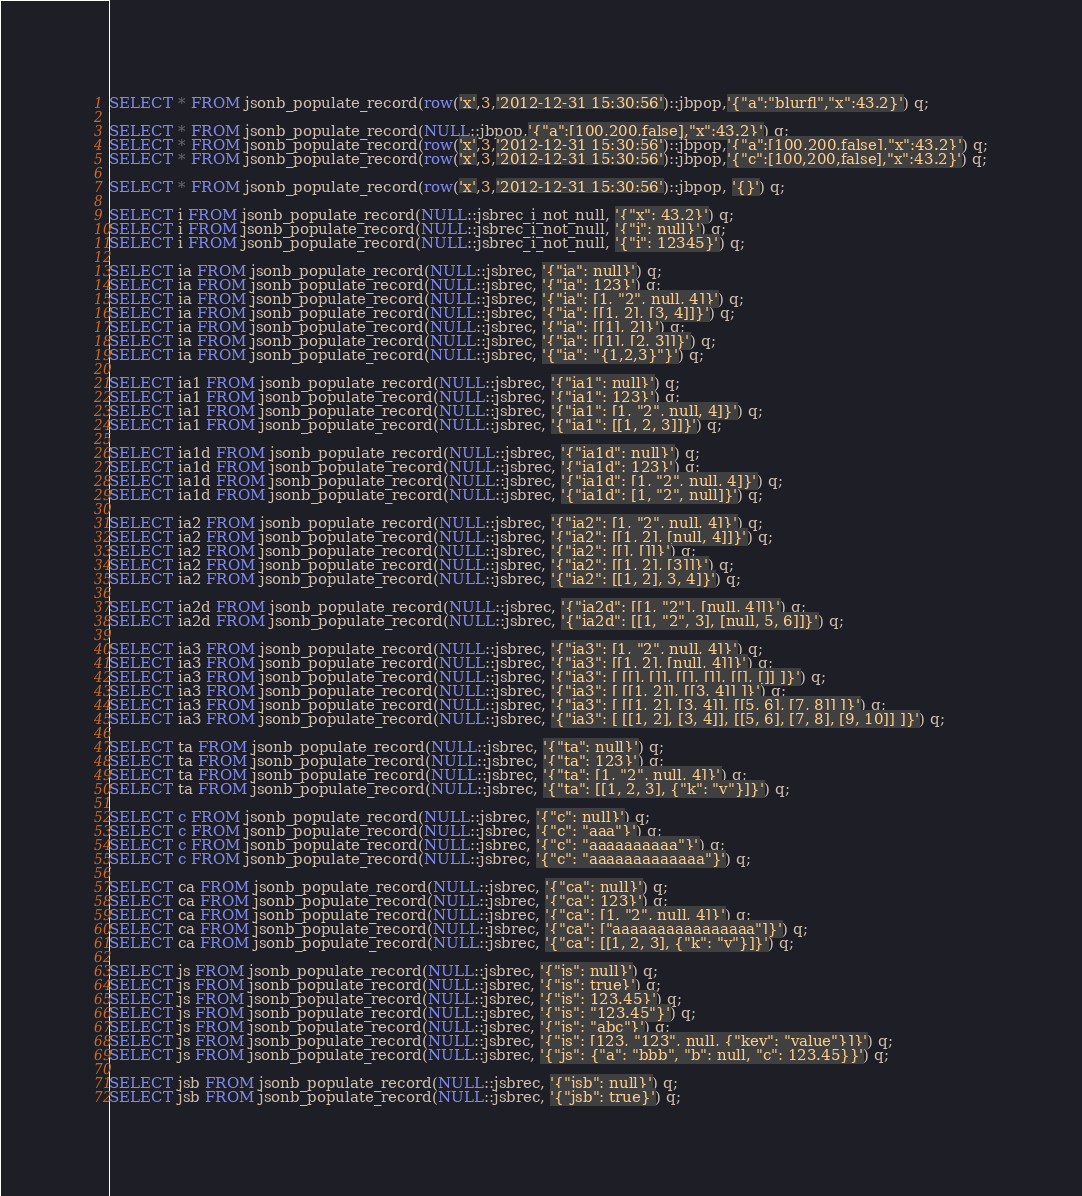Convert code to text. <code><loc_0><loc_0><loc_500><loc_500><_SQL_>SELECT * FROM jsonb_populate_record(row('x',3,'2012-12-31 15:30:56')::jbpop,'{"a":"blurfl","x":43.2}') q;

SELECT * FROM jsonb_populate_record(NULL::jbpop,'{"a":[100,200,false],"x":43.2}') q;
SELECT * FROM jsonb_populate_record(row('x',3,'2012-12-31 15:30:56')::jbpop,'{"a":[100,200,false],"x":43.2}') q;
SELECT * FROM jsonb_populate_record(row('x',3,'2012-12-31 15:30:56')::jbpop,'{"c":[100,200,false],"x":43.2}') q;

SELECT * FROM jsonb_populate_record(row('x',3,'2012-12-31 15:30:56')::jbpop, '{}') q;

SELECT i FROM jsonb_populate_record(NULL::jsbrec_i_not_null, '{"x": 43.2}') q;
SELECT i FROM jsonb_populate_record(NULL::jsbrec_i_not_null, '{"i": null}') q;
SELECT i FROM jsonb_populate_record(NULL::jsbrec_i_not_null, '{"i": 12345}') q;

SELECT ia FROM jsonb_populate_record(NULL::jsbrec, '{"ia": null}') q;
SELECT ia FROM jsonb_populate_record(NULL::jsbrec, '{"ia": 123}') q;
SELECT ia FROM jsonb_populate_record(NULL::jsbrec, '{"ia": [1, "2", null, 4]}') q;
SELECT ia FROM jsonb_populate_record(NULL::jsbrec, '{"ia": [[1, 2], [3, 4]]}') q;
SELECT ia FROM jsonb_populate_record(NULL::jsbrec, '{"ia": [[1], 2]}') q;
SELECT ia FROM jsonb_populate_record(NULL::jsbrec, '{"ia": [[1], [2, 3]]}') q;
SELECT ia FROM jsonb_populate_record(NULL::jsbrec, '{"ia": "{1,2,3}"}') q;

SELECT ia1 FROM jsonb_populate_record(NULL::jsbrec, '{"ia1": null}') q;
SELECT ia1 FROM jsonb_populate_record(NULL::jsbrec, '{"ia1": 123}') q;
SELECT ia1 FROM jsonb_populate_record(NULL::jsbrec, '{"ia1": [1, "2", null, 4]}') q;
SELECT ia1 FROM jsonb_populate_record(NULL::jsbrec, '{"ia1": [[1, 2, 3]]}') q;

SELECT ia1d FROM jsonb_populate_record(NULL::jsbrec, '{"ia1d": null}') q;
SELECT ia1d FROM jsonb_populate_record(NULL::jsbrec, '{"ia1d": 123}') q;
SELECT ia1d FROM jsonb_populate_record(NULL::jsbrec, '{"ia1d": [1, "2", null, 4]}') q;
SELECT ia1d FROM jsonb_populate_record(NULL::jsbrec, '{"ia1d": [1, "2", null]}') q;

SELECT ia2 FROM jsonb_populate_record(NULL::jsbrec, '{"ia2": [1, "2", null, 4]}') q;
SELECT ia2 FROM jsonb_populate_record(NULL::jsbrec, '{"ia2": [[1, 2], [null, 4]]}') q;
SELECT ia2 FROM jsonb_populate_record(NULL::jsbrec, '{"ia2": [[], []]}') q;
SELECT ia2 FROM jsonb_populate_record(NULL::jsbrec, '{"ia2": [[1, 2], [3]]}') q;
SELECT ia2 FROM jsonb_populate_record(NULL::jsbrec, '{"ia2": [[1, 2], 3, 4]}') q;

SELECT ia2d FROM jsonb_populate_record(NULL::jsbrec, '{"ia2d": [[1, "2"], [null, 4]]}') q;
SELECT ia2d FROM jsonb_populate_record(NULL::jsbrec, '{"ia2d": [[1, "2", 3], [null, 5, 6]]}') q;

SELECT ia3 FROM jsonb_populate_record(NULL::jsbrec, '{"ia3": [1, "2", null, 4]}') q;
SELECT ia3 FROM jsonb_populate_record(NULL::jsbrec, '{"ia3": [[1, 2], [null, 4]]}') q;
SELECT ia3 FROM jsonb_populate_record(NULL::jsbrec, '{"ia3": [ [[], []], [[], []], [[], []] ]}') q;
SELECT ia3 FROM jsonb_populate_record(NULL::jsbrec, '{"ia3": [ [[1, 2]], [[3, 4]] ]}') q;
SELECT ia3 FROM jsonb_populate_record(NULL::jsbrec, '{"ia3": [ [[1, 2], [3, 4]], [[5, 6], [7, 8]] ]}') q;
SELECT ia3 FROM jsonb_populate_record(NULL::jsbrec, '{"ia3": [ [[1, 2], [3, 4]], [[5, 6], [7, 8], [9, 10]] ]}') q;

SELECT ta FROM jsonb_populate_record(NULL::jsbrec, '{"ta": null}') q;
SELECT ta FROM jsonb_populate_record(NULL::jsbrec, '{"ta": 123}') q;
SELECT ta FROM jsonb_populate_record(NULL::jsbrec, '{"ta": [1, "2", null, 4]}') q;
SELECT ta FROM jsonb_populate_record(NULL::jsbrec, '{"ta": [[1, 2, 3], {"k": "v"}]}') q;

SELECT c FROM jsonb_populate_record(NULL::jsbrec, '{"c": null}') q;
SELECT c FROM jsonb_populate_record(NULL::jsbrec, '{"c": "aaa"}') q;
SELECT c FROM jsonb_populate_record(NULL::jsbrec, '{"c": "aaaaaaaaaa"}') q;
SELECT c FROM jsonb_populate_record(NULL::jsbrec, '{"c": "aaaaaaaaaaaaa"}') q;

SELECT ca FROM jsonb_populate_record(NULL::jsbrec, '{"ca": null}') q;
SELECT ca FROM jsonb_populate_record(NULL::jsbrec, '{"ca": 123}') q;
SELECT ca FROM jsonb_populate_record(NULL::jsbrec, '{"ca": [1, "2", null, 4]}') q;
SELECT ca FROM jsonb_populate_record(NULL::jsbrec, '{"ca": ["aaaaaaaaaaaaaaaa"]}') q;
SELECT ca FROM jsonb_populate_record(NULL::jsbrec, '{"ca": [[1, 2, 3], {"k": "v"}]}') q;

SELECT js FROM jsonb_populate_record(NULL::jsbrec, '{"js": null}') q;
SELECT js FROM jsonb_populate_record(NULL::jsbrec, '{"js": true}') q;
SELECT js FROM jsonb_populate_record(NULL::jsbrec, '{"js": 123.45}') q;
SELECT js FROM jsonb_populate_record(NULL::jsbrec, '{"js": "123.45"}') q;
SELECT js FROM jsonb_populate_record(NULL::jsbrec, '{"js": "abc"}') q;
SELECT js FROM jsonb_populate_record(NULL::jsbrec, '{"js": [123, "123", null, {"key": "value"}]}') q;
SELECT js FROM jsonb_populate_record(NULL::jsbrec, '{"js": {"a": "bbb", "b": null, "c": 123.45}}') q;

SELECT jsb FROM jsonb_populate_record(NULL::jsbrec, '{"jsb": null}') q;
SELECT jsb FROM jsonb_populate_record(NULL::jsbrec, '{"jsb": true}') q;</code> 